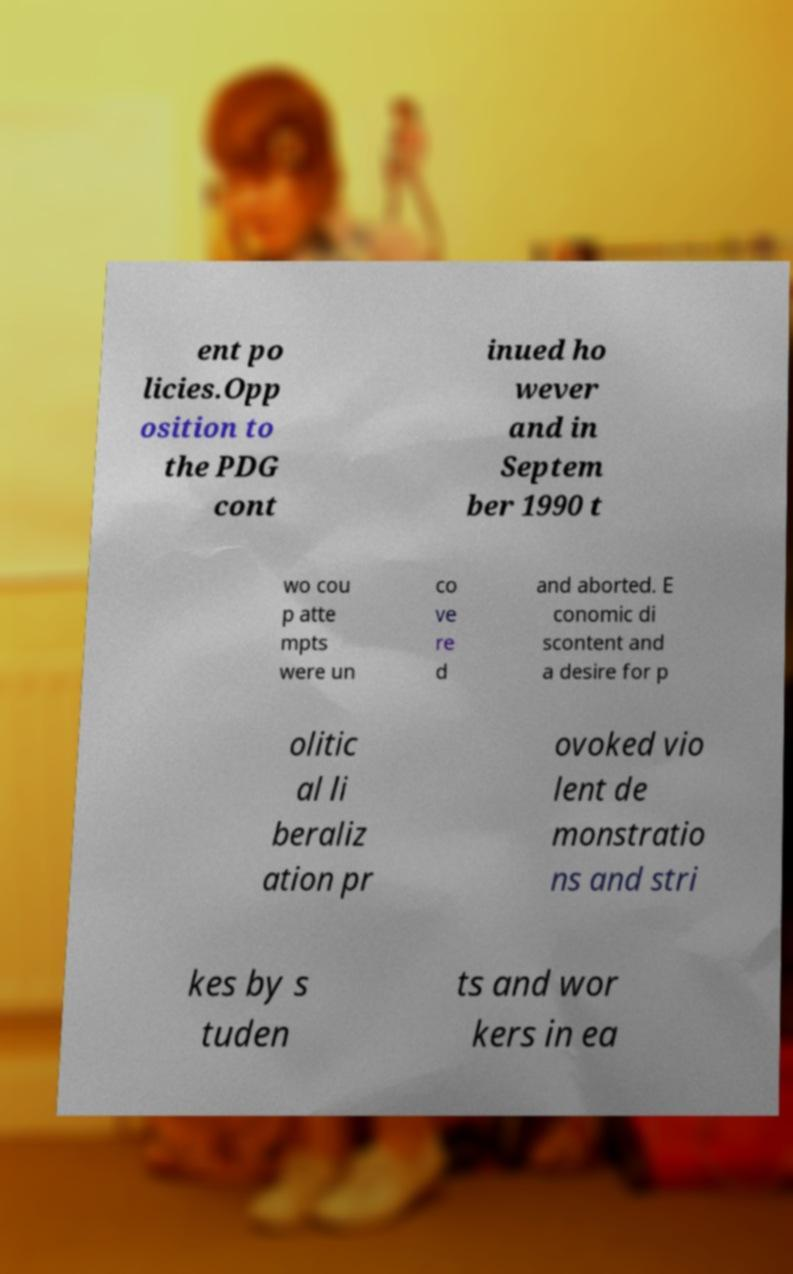I need the written content from this picture converted into text. Can you do that? ent po licies.Opp osition to the PDG cont inued ho wever and in Septem ber 1990 t wo cou p atte mpts were un co ve re d and aborted. E conomic di scontent and a desire for p olitic al li beraliz ation pr ovoked vio lent de monstratio ns and stri kes by s tuden ts and wor kers in ea 